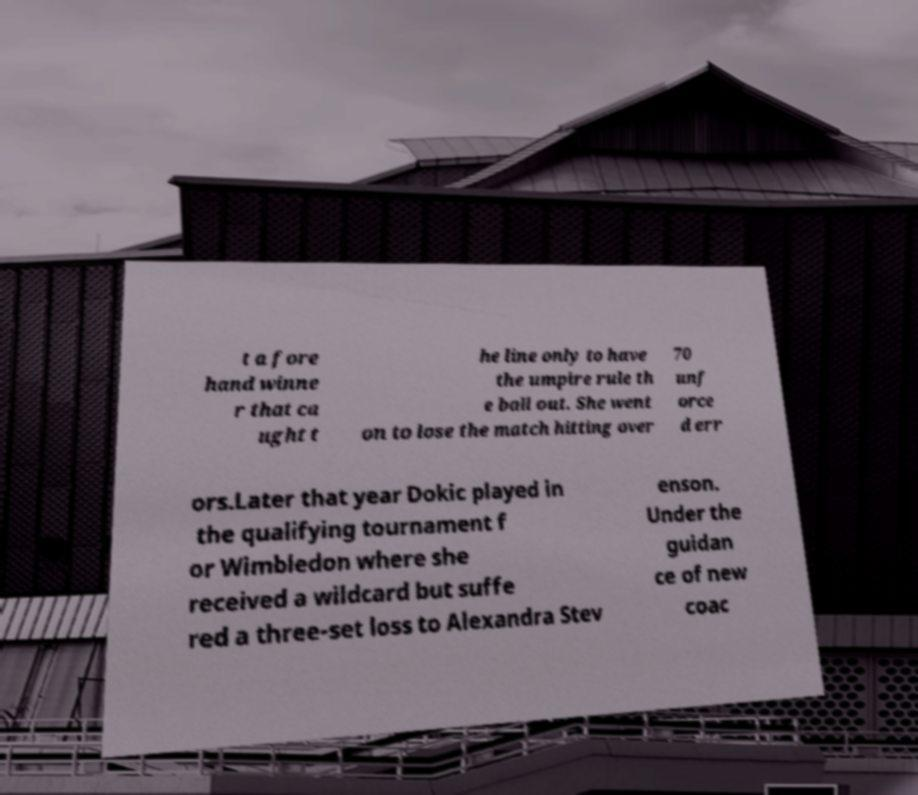Could you assist in decoding the text presented in this image and type it out clearly? t a fore hand winne r that ca ught t he line only to have the umpire rule th e ball out. She went on to lose the match hitting over 70 unf orce d err ors.Later that year Dokic played in the qualifying tournament f or Wimbledon where she received a wildcard but suffe red a three-set loss to Alexandra Stev enson. Under the guidan ce of new coac 